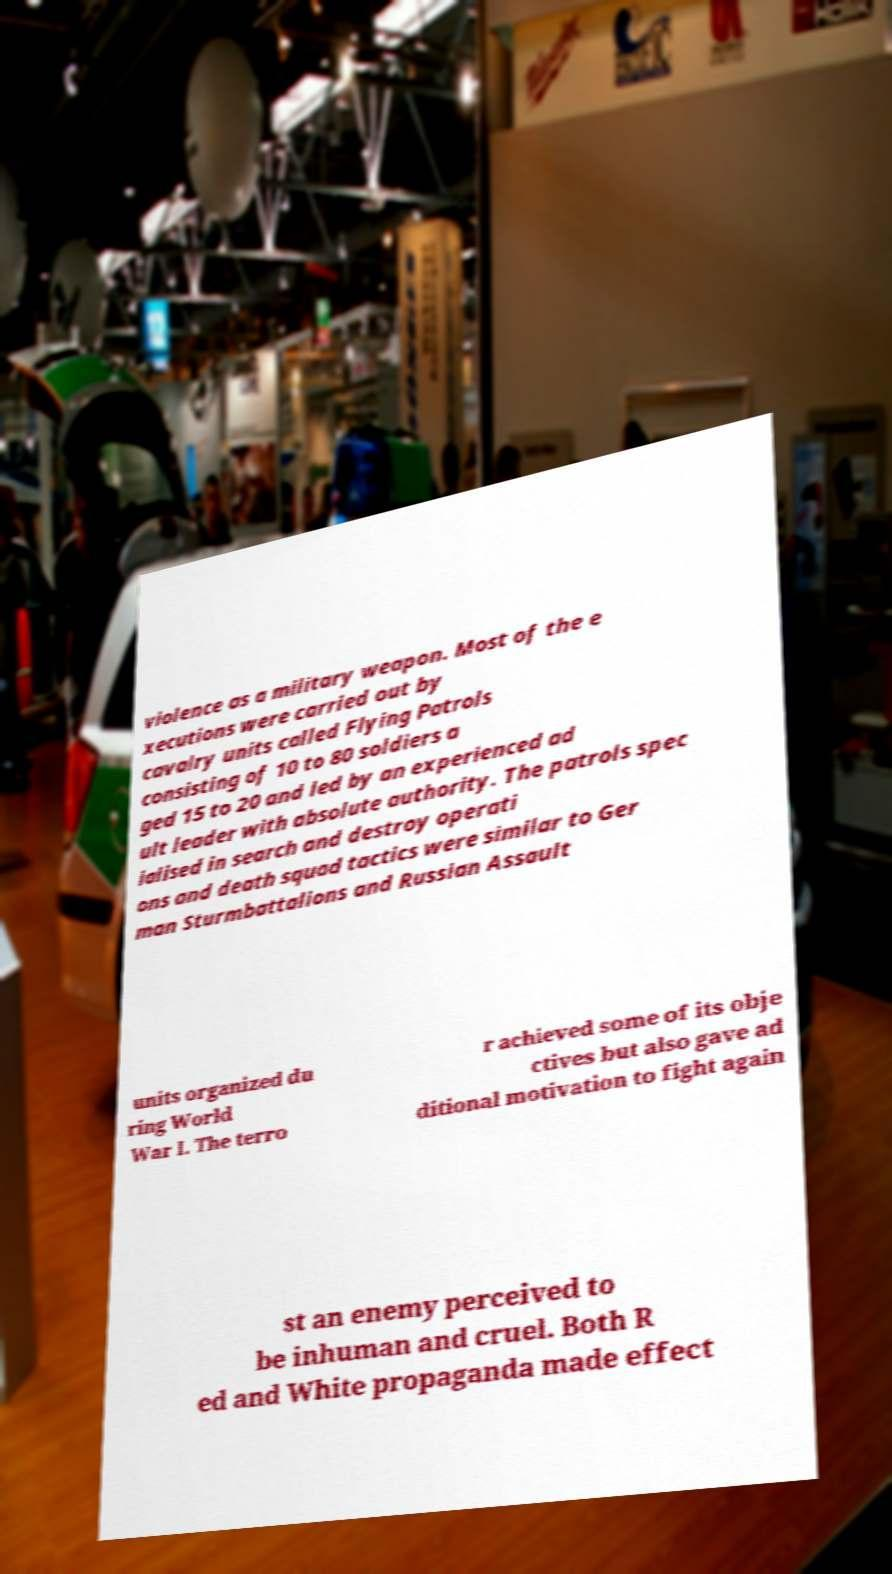For documentation purposes, I need the text within this image transcribed. Could you provide that? violence as a military weapon. Most of the e xecutions were carried out by cavalry units called Flying Patrols consisting of 10 to 80 soldiers a ged 15 to 20 and led by an experienced ad ult leader with absolute authority. The patrols spec ialised in search and destroy operati ons and death squad tactics were similar to Ger man Sturmbattalions and Russian Assault units organized du ring World War I. The terro r achieved some of its obje ctives but also gave ad ditional motivation to fight again st an enemy perceived to be inhuman and cruel. Both R ed and White propaganda made effect 